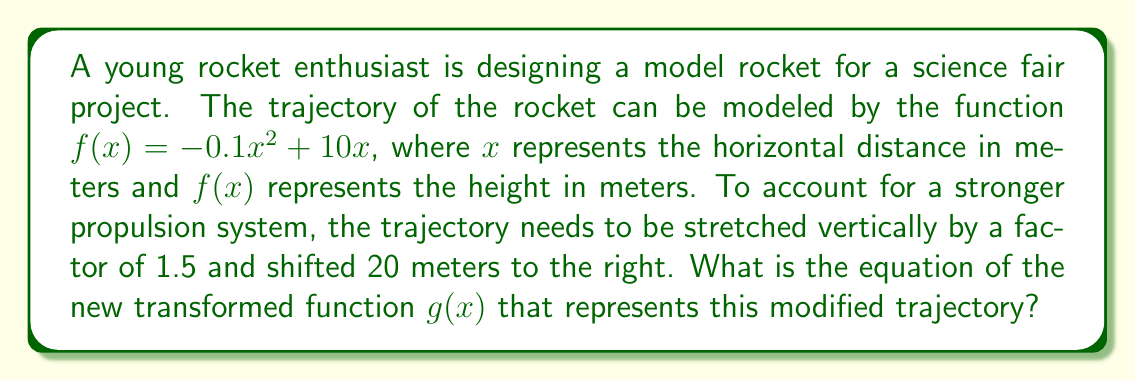Can you answer this question? Let's approach this step-by-step:

1) The original function is $f(x) = -0.1x^2 + 10x$

2) We need to apply two transformations:
   a) Stretch vertically by a factor of 1.5
   b) Shift 20 meters to the right

3) To stretch vertically by a factor of 1.5, we multiply the entire function by 1.5:
   $1.5f(x) = 1.5(-0.1x^2 + 10x) = -0.15x^2 + 15x$

4) To shift 20 meters to the right, we replace every $x$ with $(x-20)$:
   $g(x) = -0.15(x-20)^2 + 15(x-20)$

5) Let's expand this:
   $g(x) = -0.15(x^2 - 40x + 400) + 15x - 300$
   $g(x) = -0.15x^2 + 6x - 60 + 15x - 300$

6) Simplify:
   $g(x) = -0.15x^2 + 21x - 360$

Therefore, the equation of the transformed function $g(x)$ is $-0.15x^2 + 21x - 360$.
Answer: $g(x) = -0.15x^2 + 21x - 360$ 